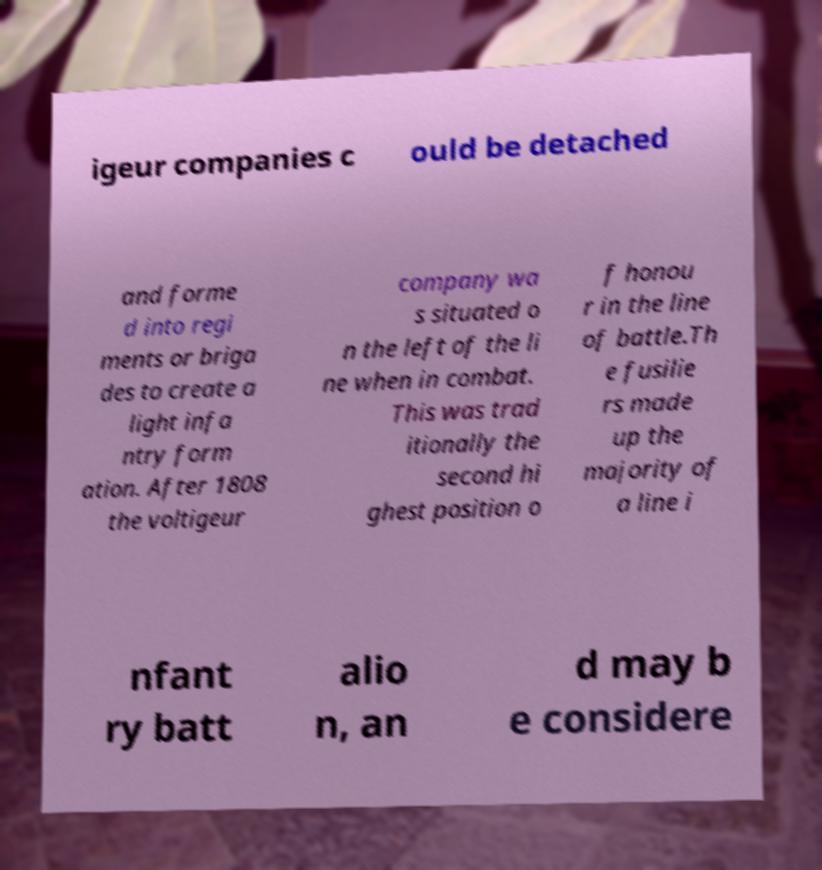Can you read and provide the text displayed in the image?This photo seems to have some interesting text. Can you extract and type it out for me? igeur companies c ould be detached and forme d into regi ments or briga des to create a light infa ntry form ation. After 1808 the voltigeur company wa s situated o n the left of the li ne when in combat. This was trad itionally the second hi ghest position o f honou r in the line of battle.Th e fusilie rs made up the majority of a line i nfant ry batt alio n, an d may b e considere 